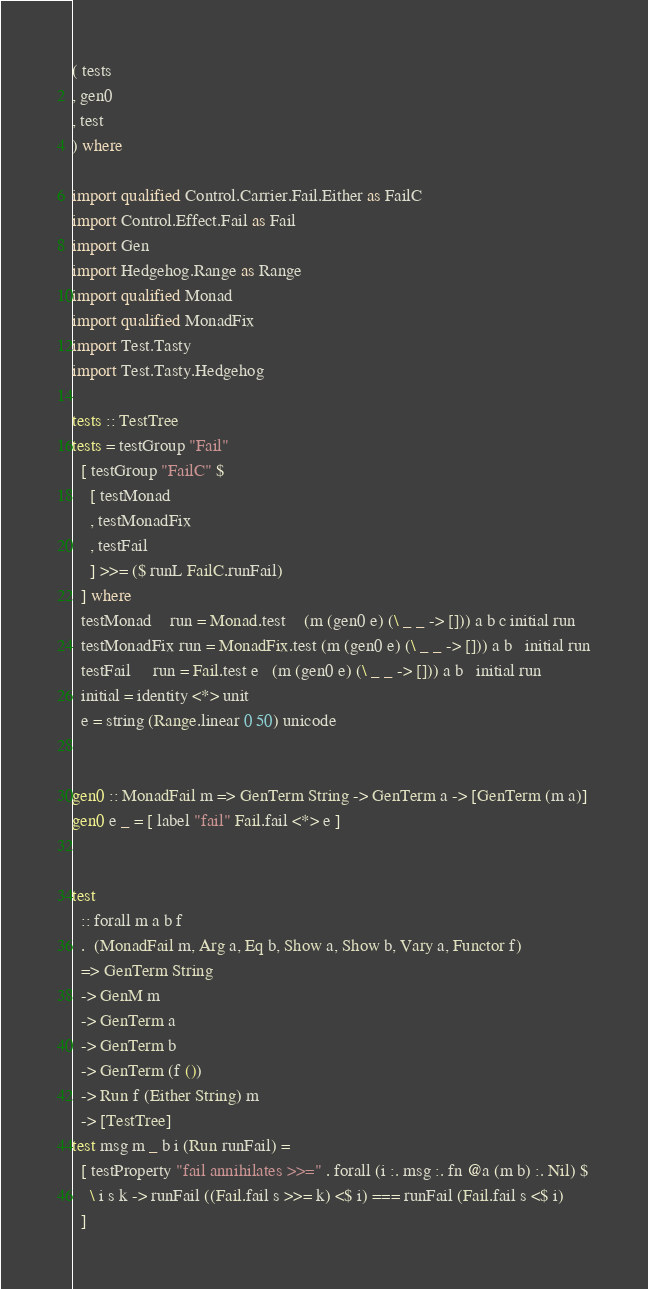<code> <loc_0><loc_0><loc_500><loc_500><_Haskell_>( tests
, gen0
, test
) where

import qualified Control.Carrier.Fail.Either as FailC
import Control.Effect.Fail as Fail
import Gen
import Hedgehog.Range as Range
import qualified Monad
import qualified MonadFix
import Test.Tasty
import Test.Tasty.Hedgehog

tests :: TestTree
tests = testGroup "Fail"
  [ testGroup "FailC" $
    [ testMonad
    , testMonadFix
    , testFail
    ] >>= ($ runL FailC.runFail)
  ] where
  testMonad    run = Monad.test    (m (gen0 e) (\ _ _ -> [])) a b c initial run
  testMonadFix run = MonadFix.test (m (gen0 e) (\ _ _ -> [])) a b   initial run
  testFail     run = Fail.test e   (m (gen0 e) (\ _ _ -> [])) a b   initial run
  initial = identity <*> unit
  e = string (Range.linear 0 50) unicode


gen0 :: MonadFail m => GenTerm String -> GenTerm a -> [GenTerm (m a)]
gen0 e _ = [ label "fail" Fail.fail <*> e ]


test
  :: forall m a b f
  .  (MonadFail m, Arg a, Eq b, Show a, Show b, Vary a, Functor f)
  => GenTerm String
  -> GenM m
  -> GenTerm a
  -> GenTerm b
  -> GenTerm (f ())
  -> Run f (Either String) m
  -> [TestTree]
test msg m _ b i (Run runFail) =
  [ testProperty "fail annihilates >>=" . forall (i :. msg :. fn @a (m b) :. Nil) $
    \ i s k -> runFail ((Fail.fail s >>= k) <$ i) === runFail (Fail.fail s <$ i)
  ]
</code> 